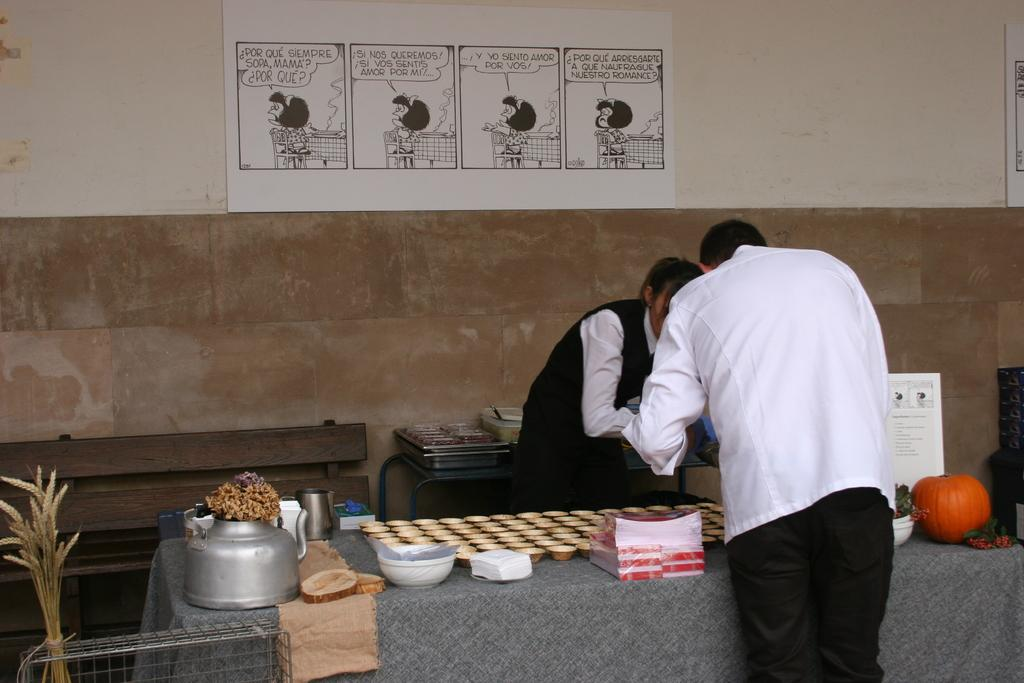How many people are in the image? There are two persons in the image, one on each side of the table. What objects are on the table? There is a kettle, cups, a bowl, a glass, and a pumpkin on the table. What is on the wall in the background? There is a poster on the wall in the background. What furniture is visible in the background? There is a bench and a table in the background. How many basketballs are on the table in the image? There are no basketballs present in the image; the objects on the table include a kettle, cups, a bowl, a glass, and a pumpkin. 